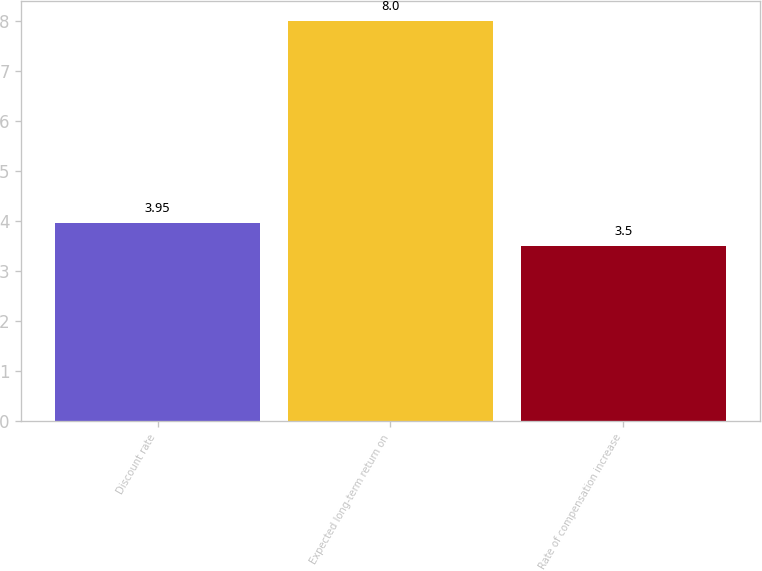Convert chart to OTSL. <chart><loc_0><loc_0><loc_500><loc_500><bar_chart><fcel>Discount rate<fcel>Expected long-term return on<fcel>Rate of compensation increase<nl><fcel>3.95<fcel>8<fcel>3.5<nl></chart> 